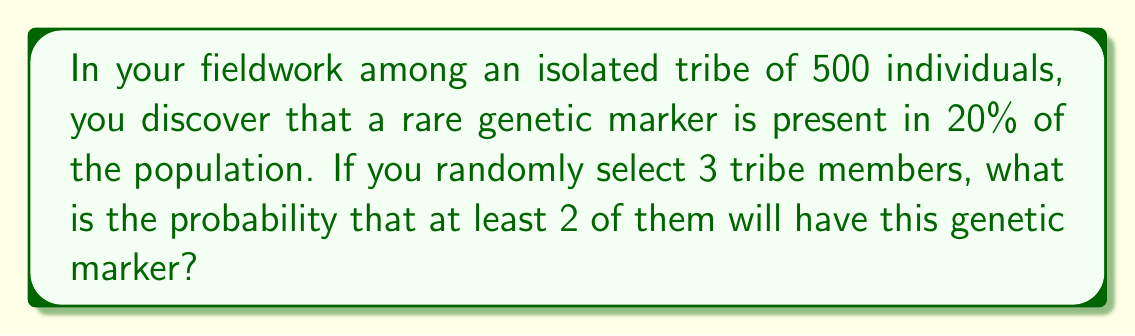Give your solution to this math problem. Let's approach this step-by-step:

1) First, we need to calculate the probability of selecting an individual with the genetic marker. This is given as 20% or 0.2.

2) The probability of selecting an individual without the marker is therefore 1 - 0.2 = 0.8.

3) We want the probability of at least 2 out of 3 people having the marker. This can happen in two ways:
   a) All 3 have the marker
   b) Exactly 2 out of 3 have the marker

4) Let's calculate these probabilities:

   a) P(all 3 have the marker) = $0.2 \times 0.2 \times 0.2 = 0.2^3 = 0.008$

   b) P(exactly 2 out of 3 have the marker) = $\binom{3}{2} \times 0.2^2 \times 0.8$
      
      Here, $\binom{3}{2} = 3$ is the number of ways to choose 2 people out of 3.
      
      So, this probability is $3 \times 0.2^2 \times 0.8 = 3 \times 0.04 \times 0.8 = 0.096$

5) The total probability is the sum of these two probabilities:

   P(at least 2 out of 3 have the marker) = $0.008 + 0.096 = 0.104$

6) Therefore, the probability is 0.104 or 10.4%.
Answer: 0.104 